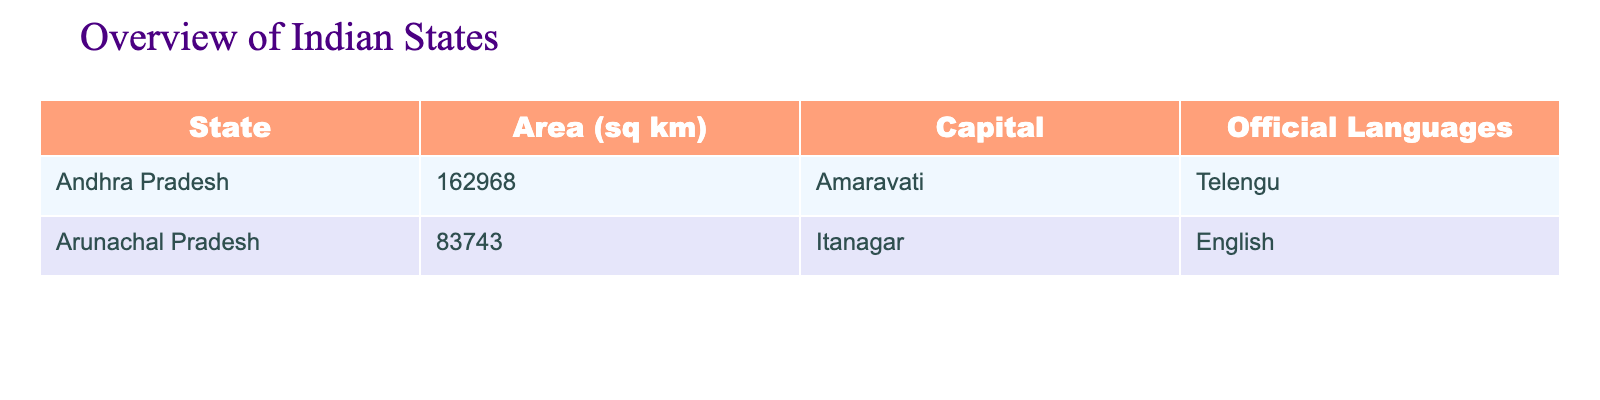What is the area of Andhra Pradesh? The table lists the area of Andhra Pradesh as 162968 sq km under the area column.
Answer: 162968 sq km What is the capital of Arunachal Pradesh? According to the table, the capital of Arunachal Pradesh is mentioned as Itanagar in the capital column.
Answer: Itanagar Which state has English as its official language? By looking at the official languages column, Arunachal Pradesh is the only state that lists English as its official language.
Answer: Arunachal Pradesh Is Amaravati the capital of Andhra Pradesh? The table clearly states that the capital of Andhra Pradesh is Amaravati, confirming the given fact as true.
Answer: Yes What is the total area of both states combined? To find the total area, we add the area of Andhra Pradesh (162968 sq km) and Arunachal Pradesh (83743 sq km): 162968 + 83743 = 246711 sq km.
Answer: 246711 sq km Which state has a larger area, Andhra Pradesh or Arunachal Pradesh? The area of Andhra Pradesh is 162968 sq km and Arunachal Pradesh is 83743 sq km. Since 162968 is greater than 83743, Andhra Pradesh has the larger area.
Answer: Andhra Pradesh What is the average area of the two states? To calculate the average area, add the areas of both states: 162968 + 83743 = 246711 sq km. Then, divide by the number of states (2): 246711 / 2 = 123355.5 sq km.
Answer: 123355.5 sq km Do both states have the same official language? Checking the official languages column, Andhra Pradesh has Telugu, while Arunachal Pradesh has English, showing that they do not have the same official language.
Answer: No Which state has a capital that starts with the letter 'A'? The capital of Andhra Pradesh is Amaravati and it starts with 'A'. Therefore, the state that meets this criterion is Andhra Pradesh.
Answer: Andhra Pradesh 